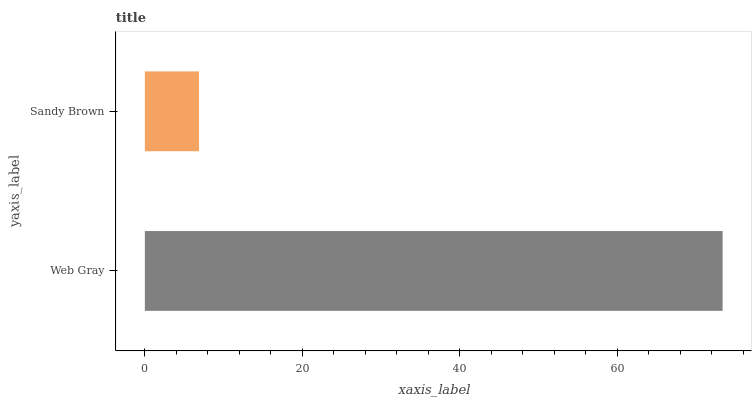Is Sandy Brown the minimum?
Answer yes or no. Yes. Is Web Gray the maximum?
Answer yes or no. Yes. Is Sandy Brown the maximum?
Answer yes or no. No. Is Web Gray greater than Sandy Brown?
Answer yes or no. Yes. Is Sandy Brown less than Web Gray?
Answer yes or no. Yes. Is Sandy Brown greater than Web Gray?
Answer yes or no. No. Is Web Gray less than Sandy Brown?
Answer yes or no. No. Is Web Gray the high median?
Answer yes or no. Yes. Is Sandy Brown the low median?
Answer yes or no. Yes. Is Sandy Brown the high median?
Answer yes or no. No. Is Web Gray the low median?
Answer yes or no. No. 